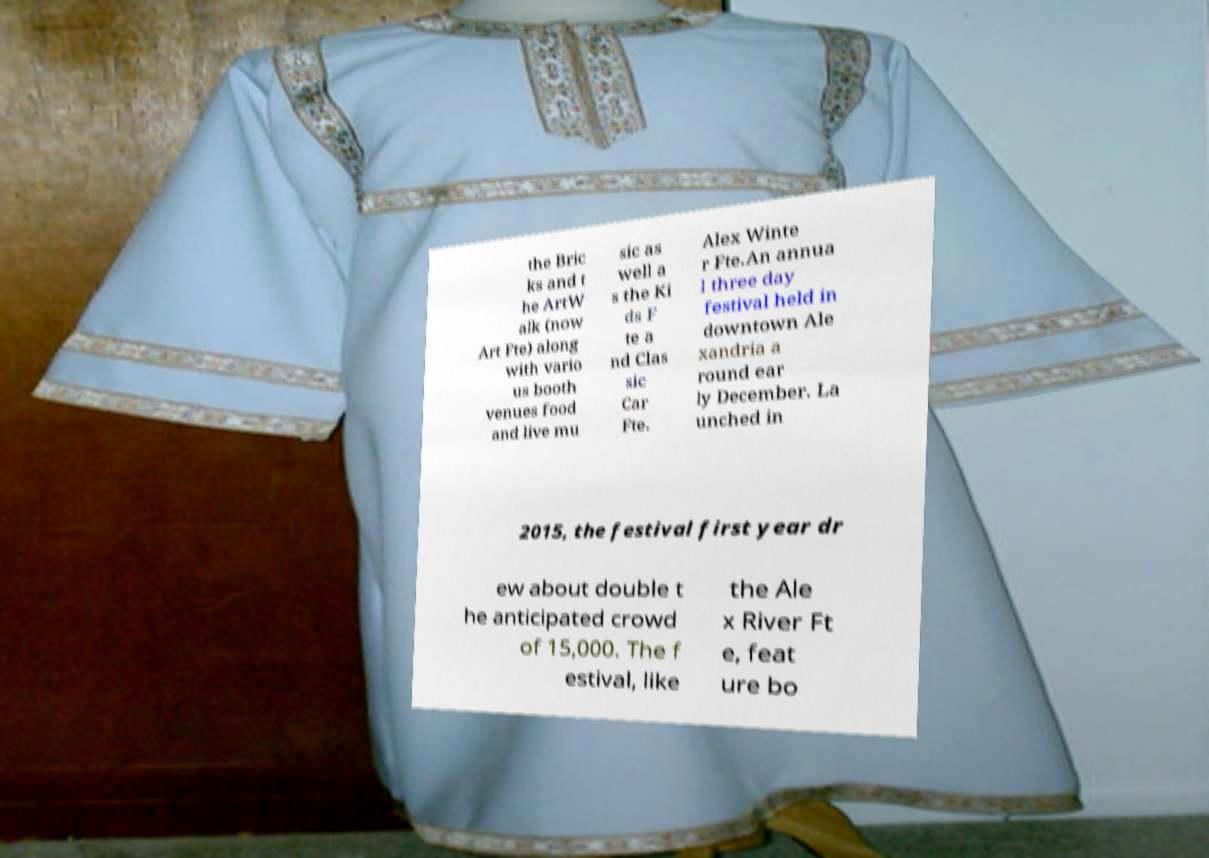What messages or text are displayed in this image? I need them in a readable, typed format. the Bric ks and t he ArtW alk (now Art Fte) along with vario us booth venues food and live mu sic as well a s the Ki ds F te a nd Clas sic Car Fte. Alex Winte r Fte.An annua l three day festival held in downtown Ale xandria a round ear ly December. La unched in 2015, the festival first year dr ew about double t he anticipated crowd of 15,000. The f estival, like the Ale x River Ft e, feat ure bo 